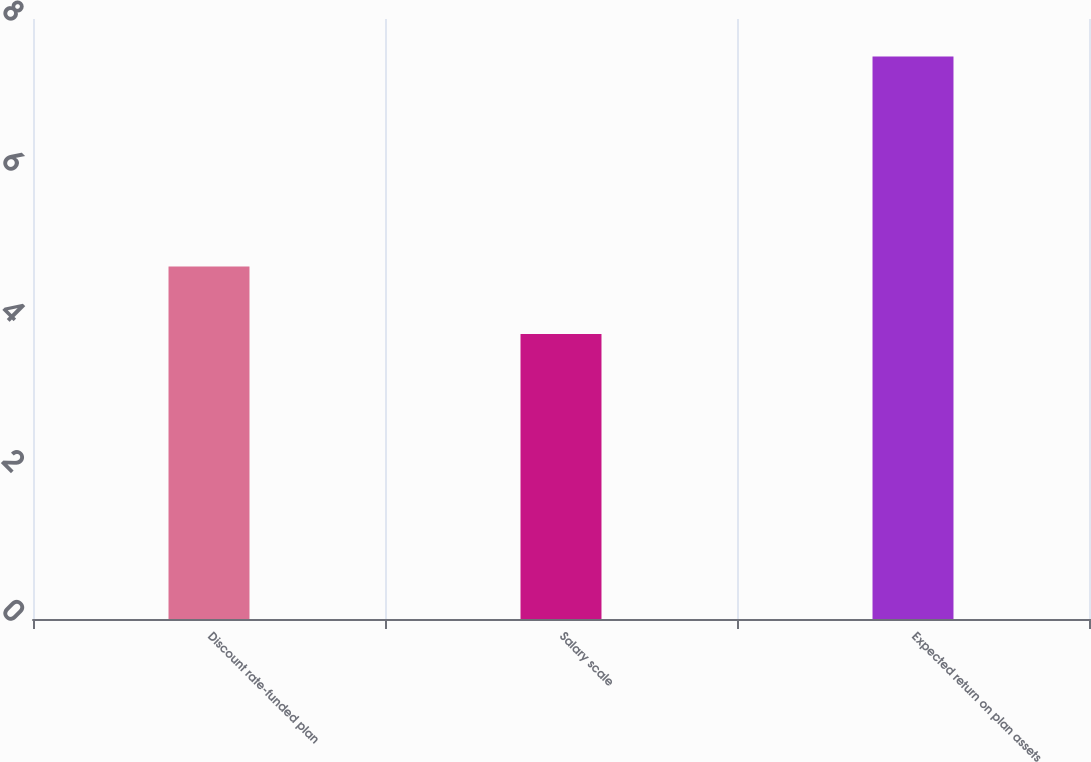<chart> <loc_0><loc_0><loc_500><loc_500><bar_chart><fcel>Discount rate-funded plan<fcel>Salary scale<fcel>Expected return on plan assets<nl><fcel>4.7<fcel>3.8<fcel>7.5<nl></chart> 